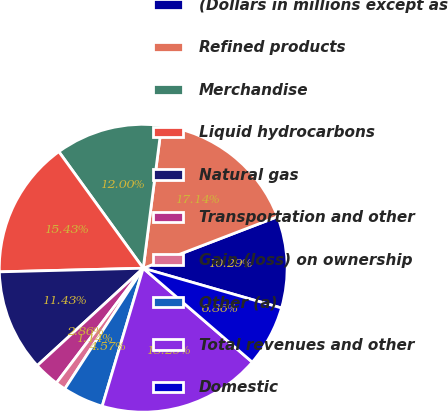Convert chart. <chart><loc_0><loc_0><loc_500><loc_500><pie_chart><fcel>(Dollars in millions except as<fcel>Refined products<fcel>Merchandise<fcel>Liquid hydrocarbons<fcel>Natural gas<fcel>Transportation and other<fcel>Gain (loss) on ownership<fcel>Other (a)<fcel>Total revenues and other<fcel>Domestic<nl><fcel>10.29%<fcel>17.14%<fcel>12.0%<fcel>15.43%<fcel>11.43%<fcel>2.86%<fcel>1.14%<fcel>4.57%<fcel>18.29%<fcel>6.86%<nl></chart> 